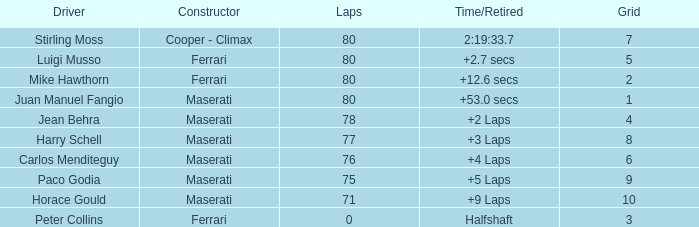What is the average grid spot for a maserati that has finished under 80 laps and possesses a time/retired figure of an additional two laps? 4.0. 